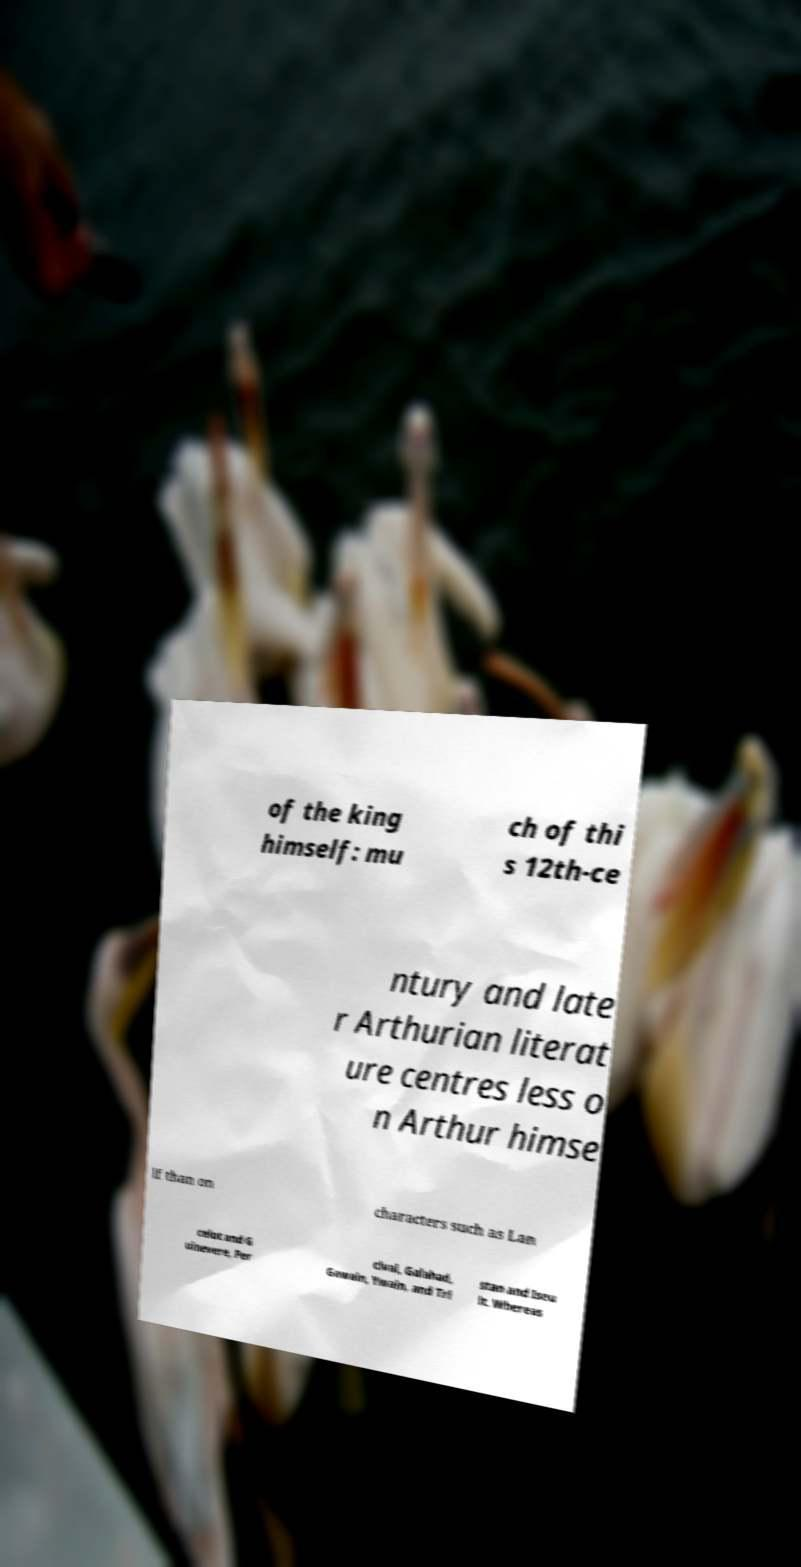Please identify and transcribe the text found in this image. of the king himself: mu ch of thi s 12th-ce ntury and late r Arthurian literat ure centres less o n Arthur himse lf than on characters such as Lan celot and G uinevere, Per cival, Galahad, Gawain, Ywain, and Tri stan and Iseu lt. Whereas 